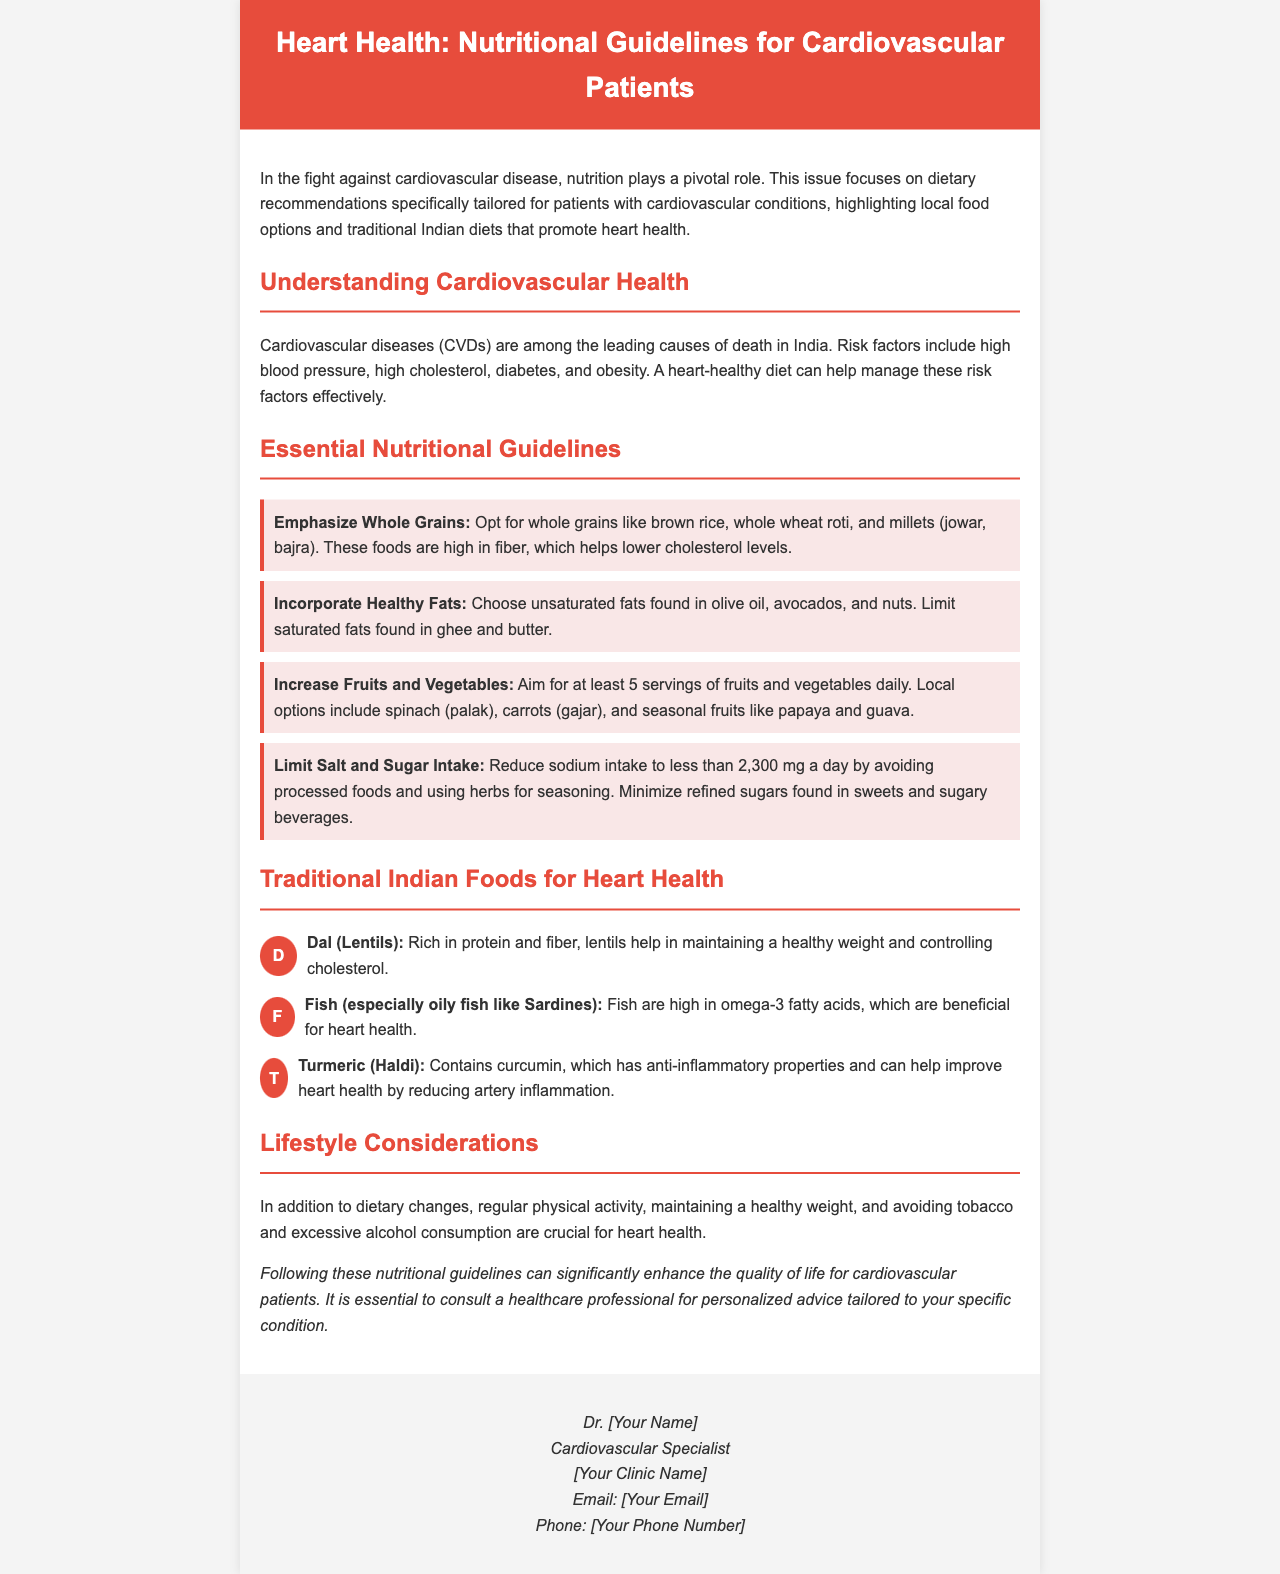what are the leading causes of death in India? The document states that cardiovascular diseases (CVDs) are among the leading causes of death in India.
Answer: cardiovascular diseases how much sodium intake is recommended daily? The document recommends reducing sodium intake to less than 2,300 mg a day for cardiovascular patients.
Answer: less than 2,300 mg name a whole grain recommended in the guidelines. The document mentions whole grains like brown rice, whole wheat roti, and millets.
Answer: brown rice which fish is highlighted for its omega-3 fatty acids? The document specifically highlights oily fish like Sardines for their omega-3 fatty acids.
Answer: Sardines what can help reduce artery inflammation according to the document? The document indicates that turmeric (haldi), which contains curcumin, can help improve heart health by reducing artery inflammation.
Answer: turmeric (haldi) what physical activity recommendation is mentioned for heart health? The document emphasizes that regular physical activity is crucial for heart health.
Answer: regular physical activity how many servings of fruits and vegetables should one aim for daily? The document advises aiming for at least 5 servings of fruits and vegetables daily.
Answer: at least 5 servings what lifestyle change is emphasized alongside dietary changes? The document mentions that maintaining a healthy weight is crucial for heart health alongside dietary changes.
Answer: maintaining a healthy weight 